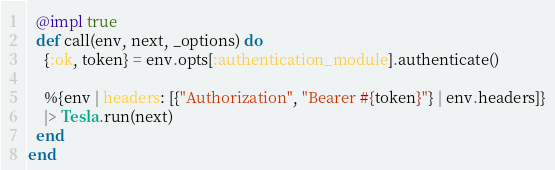<code> <loc_0><loc_0><loc_500><loc_500><_Elixir_>  @impl true
  def call(env, next, _options) do
    {:ok, token} = env.opts[:authentication_module].authenticate()

    %{env | headers: [{"Authorization", "Bearer #{token}"} | env.headers]}
    |> Tesla.run(next)
  end
end
</code> 